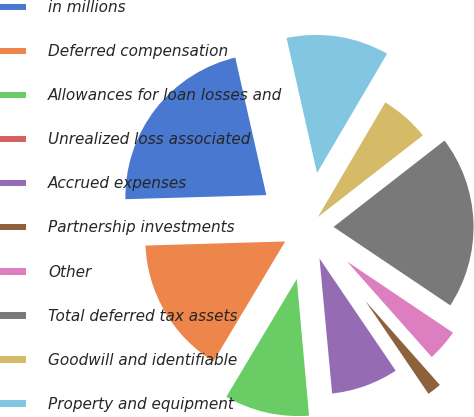Convert chart to OTSL. <chart><loc_0><loc_0><loc_500><loc_500><pie_chart><fcel>in millions<fcel>Deferred compensation<fcel>Allowances for loan losses and<fcel>Unrealized loss associated<fcel>Accrued expenses<fcel>Partnership investments<fcel>Other<fcel>Total deferred tax assets<fcel>Goodwill and identifiable<fcel>Property and equipment<nl><fcel>21.93%<fcel>15.96%<fcel>10.0%<fcel>0.06%<fcel>8.01%<fcel>2.05%<fcel>4.04%<fcel>19.94%<fcel>6.02%<fcel>11.99%<nl></chart> 